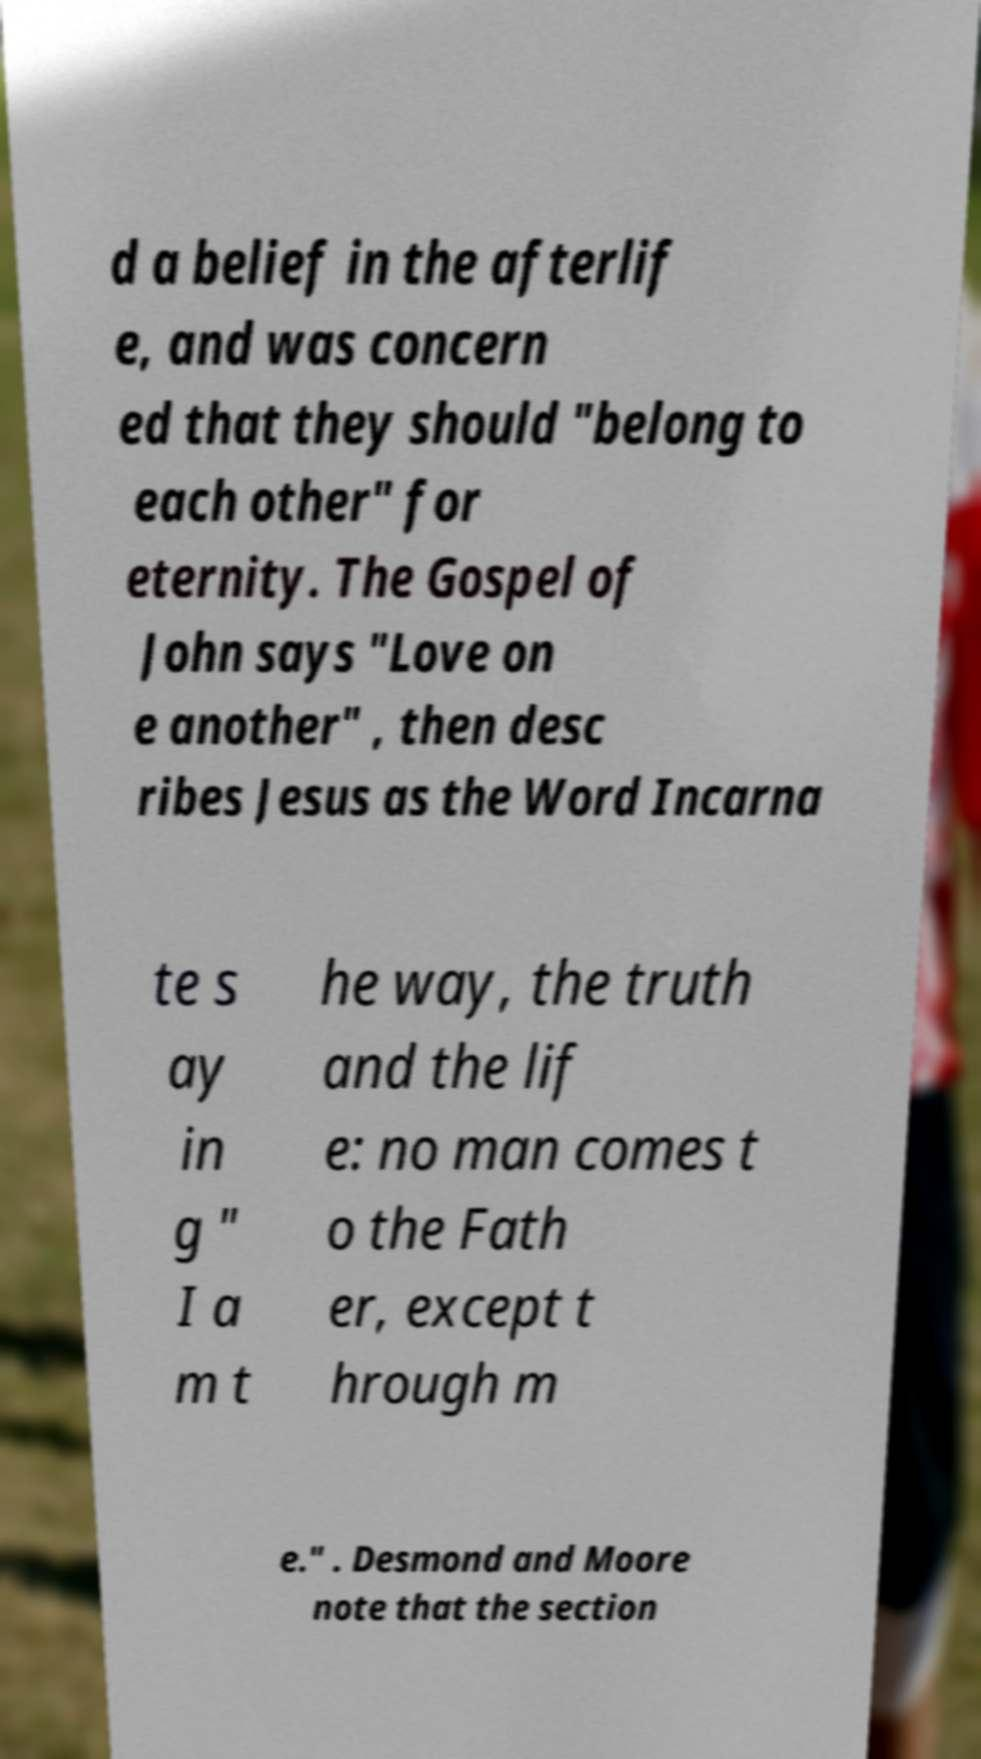What messages or text are displayed in this image? I need them in a readable, typed format. d a belief in the afterlif e, and was concern ed that they should "belong to each other" for eternity. The Gospel of John says "Love on e another" , then desc ribes Jesus as the Word Incarna te s ay in g " I a m t he way, the truth and the lif e: no man comes t o the Fath er, except t hrough m e." . Desmond and Moore note that the section 